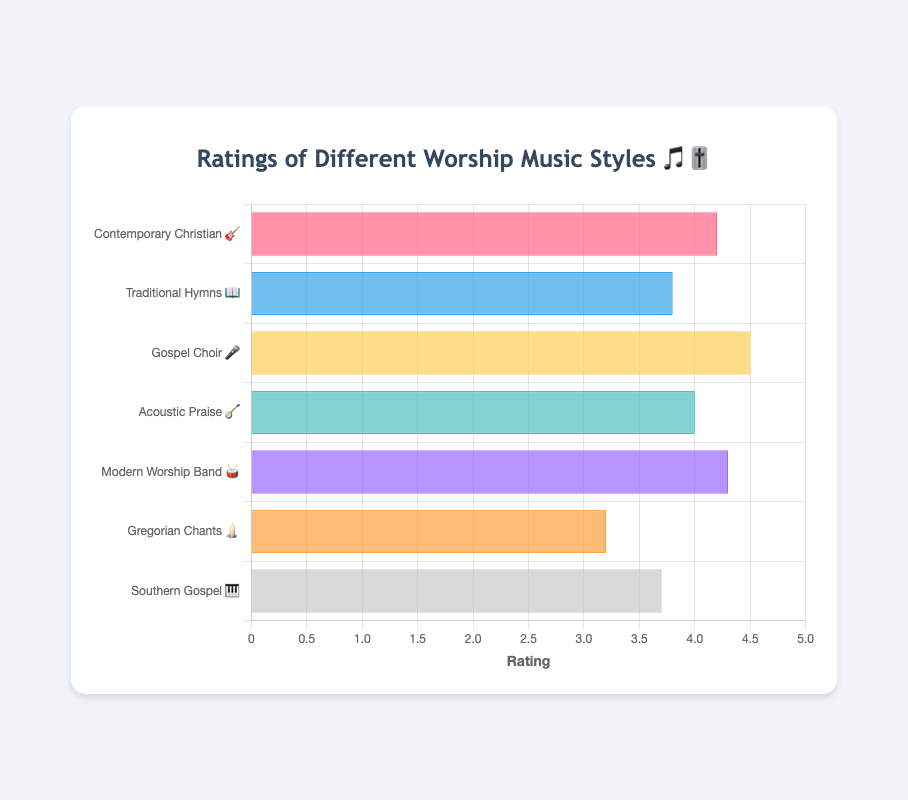What is the title of the chart? The title of the chart is displayed at the top and reads "Ratings of Different Worship Music Styles 🎵🎚️".
Answer: Ratings of Different Worship Music Styles 🎵🎚️ Which worship music style received the highest rating? The chart shows ratings for different worship music styles. The bar labeled "Gospel Choir 🎤" extends the farthest on the rating scale, indicating it received the highest rating.
Answer: Gospel Choir 🎤 What is the rating of the Traditional Hymns 📖 style? Looking at the bar for Traditional Hymns 📖, it reaches the 3.8 mark on the x-axis, indicating its rating.
Answer: 3.8 How much higher is the rating for Gospel Choir 🎤 compared to Gregorian Chants 🕯️? The rating for Gospel Choir 🎤 is 4.5, and the rating for Gregorian Chants 🕯️ is 3.2. Subtracting 3.2 from 4.5 gives the difference. 4.5 - 3.2 = 1.3.
Answer: 1.3 Which worship music styles have ratings above 4.0? The bars for the styles Contemporary Christian 🎸, Gospel Choir 🎤, Acoustic Praise 🪕, and Modern Worship Band 🥁 all extend beyond the 4.0 mark on the x-axis.
Answer: Contemporary Christian 🎸, Gospel Choir 🎤, Acoustic Praise 🪕, Modern Worship Band 🥁 What is the average rating of all the worship music styles? Add all the ratings together (4.2 + 3.8 + 4.5 + 4.0 + 4.3 + 3.2 + 3.7) and then divide by the number of styles (7). The sum is 27.7 and dividing by 7 gives approximately 3.96. 27.7 / 7 ≈ 3.96.
Answer: 3.96 Between Contemporary Christian 🎸 and Southern Gospel 🎹, which style has a higher rating? By comparing the two bars, Contemporary Christian 🎸 has a rating of 4.2, while Southern Gospel 🎹 has a rating of 3.7. Since 4.2 is greater than 3.7, Contemporary Christian 🎸 has a higher rating.
Answer: Contemporary Christian 🎸 What is the combined rating of Contemporary Christian 🎸 and Modern Worship Band 🥁? The rating for Contemporary Christian 🎸 is 4.2 and for Modern Worship Band 🥁 is 4.3. Adding these two ratings gives 4.2 + 4.3 = 8.5.
Answer: 8.5 Which worship music style has the lowest rating? The shortest bar represents Gregorian Chants 🕯️, indicating it has the lowest rating of all the styles displayed.
Answer: Gregorian Chants 🕯️ What is the difference in rating between the highest and lowest rated worship music styles? The highest rating is for Gospel Choir 🎤 at 4.5 and the lowest is for Gregorian Chants 🕯️ at 3.2. Subtracting the lowest rating from the highest gives 4.5 - 3.2 = 1.3.
Answer: 1.3 